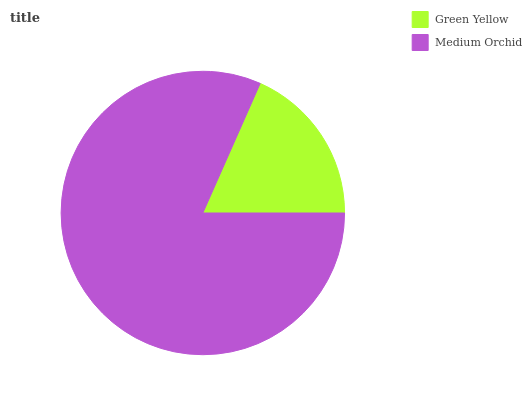Is Green Yellow the minimum?
Answer yes or no. Yes. Is Medium Orchid the maximum?
Answer yes or no. Yes. Is Medium Orchid the minimum?
Answer yes or no. No. Is Medium Orchid greater than Green Yellow?
Answer yes or no. Yes. Is Green Yellow less than Medium Orchid?
Answer yes or no. Yes. Is Green Yellow greater than Medium Orchid?
Answer yes or no. No. Is Medium Orchid less than Green Yellow?
Answer yes or no. No. Is Medium Orchid the high median?
Answer yes or no. Yes. Is Green Yellow the low median?
Answer yes or no. Yes. Is Green Yellow the high median?
Answer yes or no. No. Is Medium Orchid the low median?
Answer yes or no. No. 